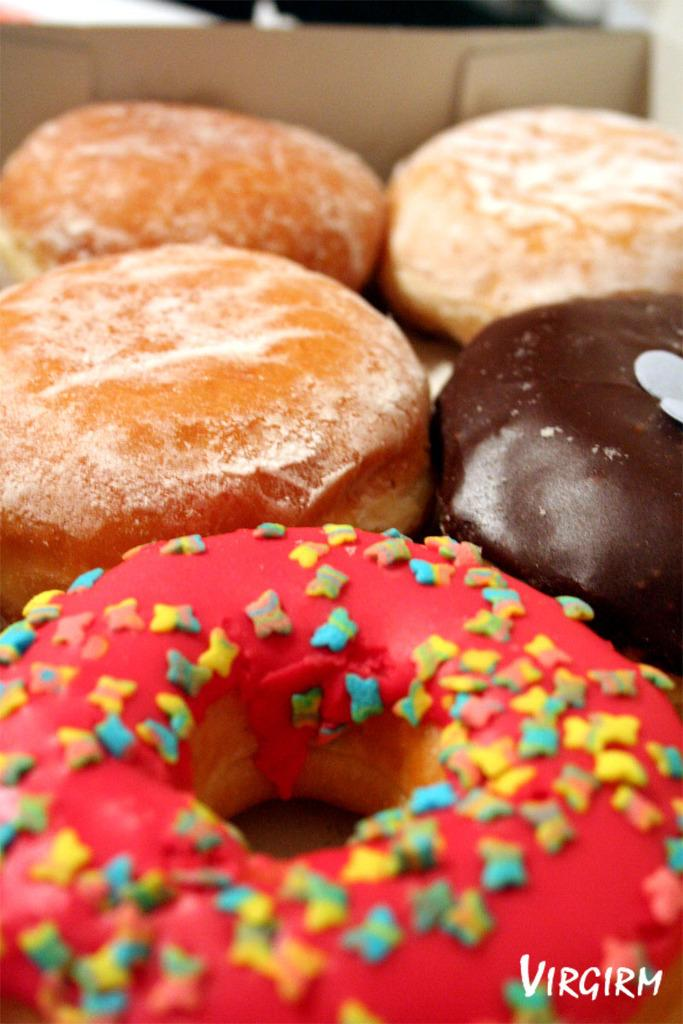What type of food is visible in the image? There are doughnuts in the image. How are the doughnuts contained in the image? The doughnuts are in a box. Is there any text present in the image? Yes, there is text at the bottom of the image. What type of needle is used to sew the root of the toy in the image? There is no needle, root, or toy present in the image. 